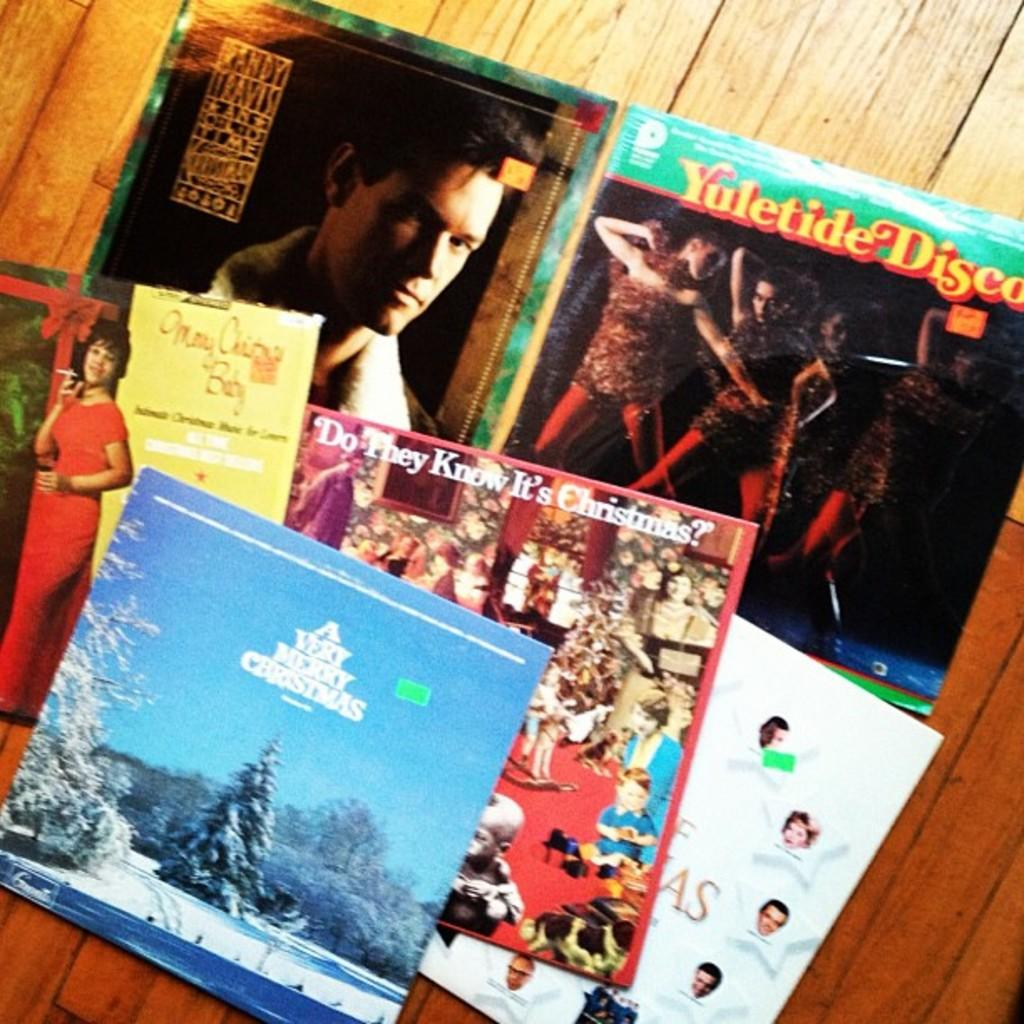Provide a one-sentence caption for the provided image. A collection of albums includes A Very Merry Christmas. 